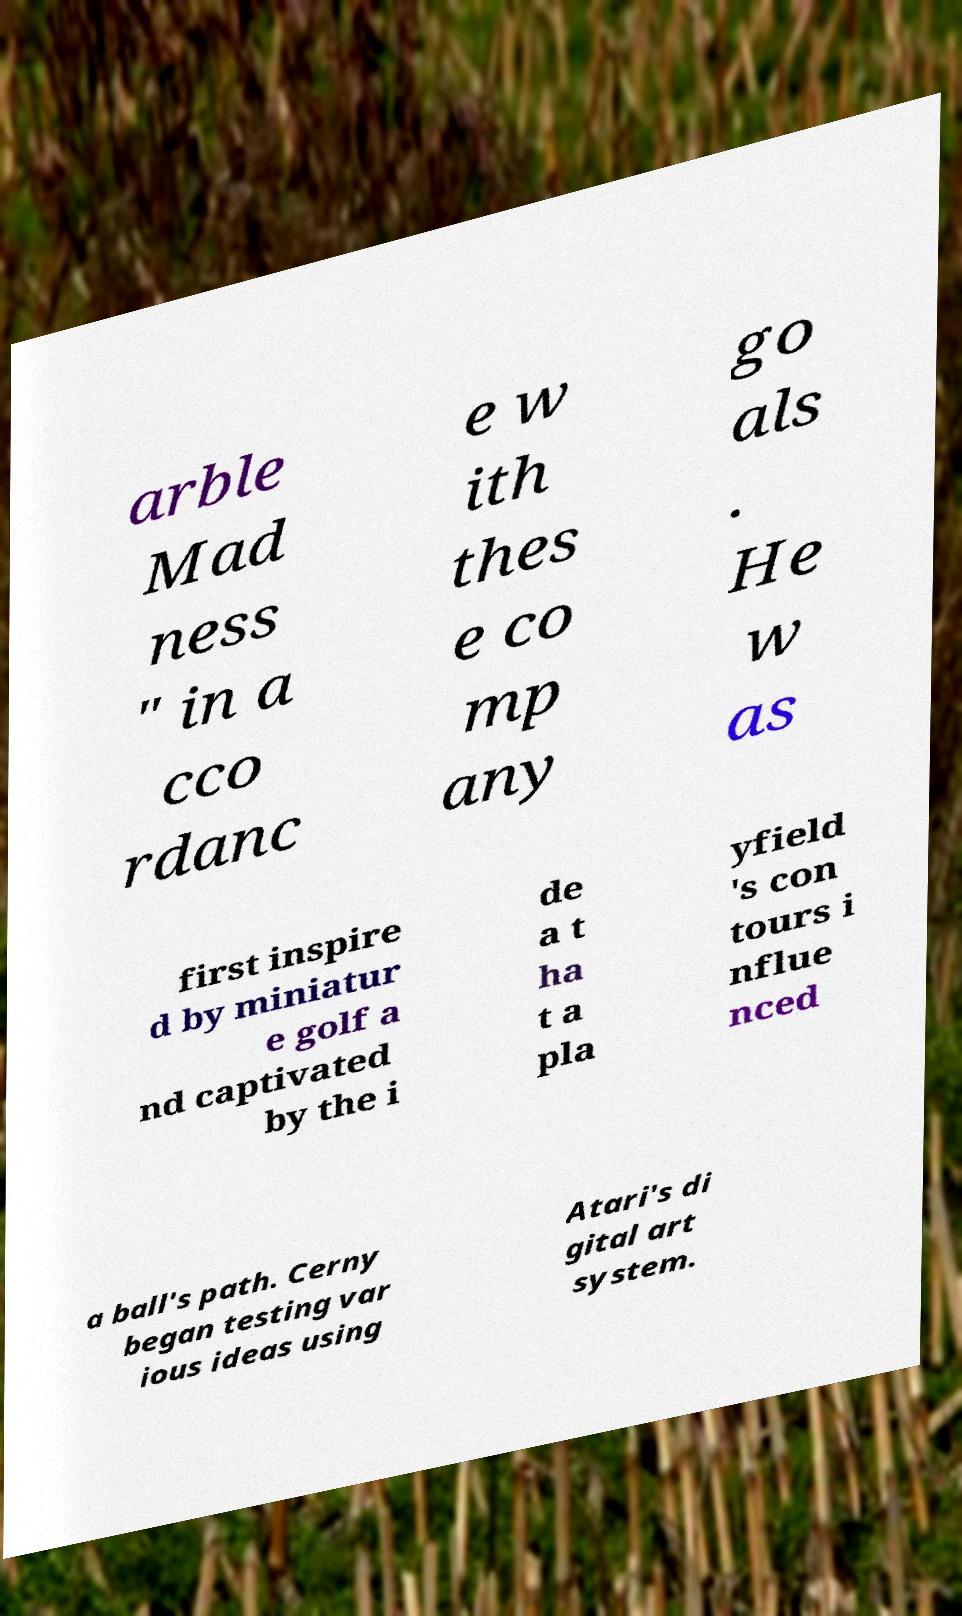What messages or text are displayed in this image? I need them in a readable, typed format. arble Mad ness " in a cco rdanc e w ith thes e co mp any go als . He w as first inspire d by miniatur e golf a nd captivated by the i de a t ha t a pla yfield 's con tours i nflue nced a ball's path. Cerny began testing var ious ideas using Atari's di gital art system. 